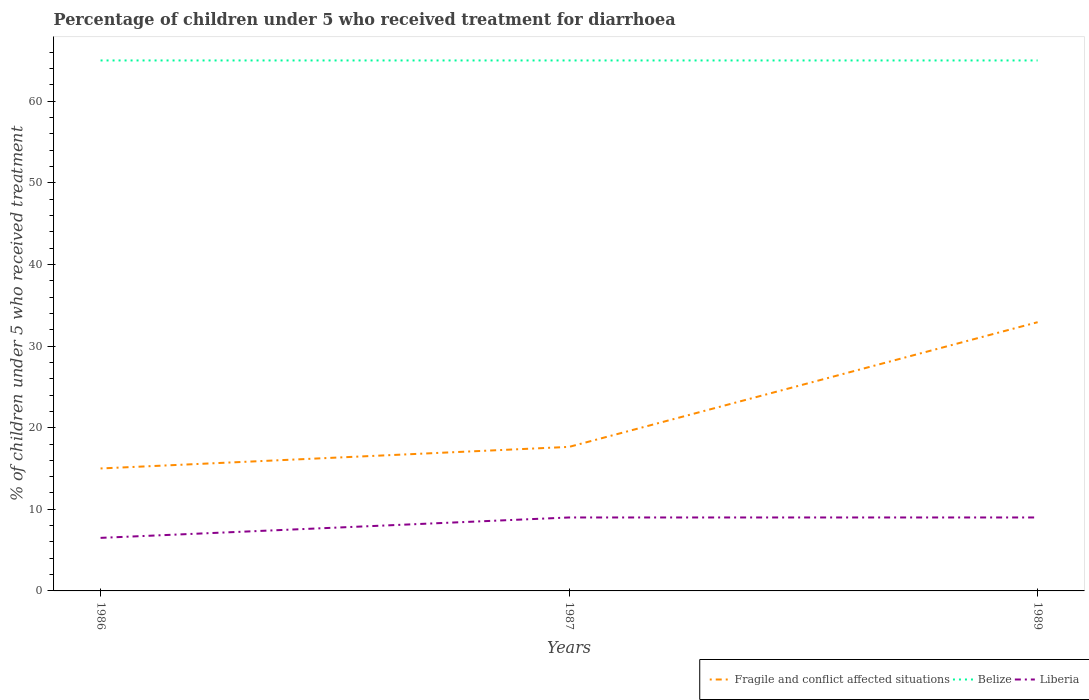How many different coloured lines are there?
Your response must be concise. 3. Across all years, what is the maximum percentage of children who received treatment for diarrhoea  in Fragile and conflict affected situations?
Offer a terse response. 15.01. What is the total percentage of children who received treatment for diarrhoea  in Fragile and conflict affected situations in the graph?
Ensure brevity in your answer.  -2.64. What is the difference between the highest and the second highest percentage of children who received treatment for diarrhoea  in Fragile and conflict affected situations?
Ensure brevity in your answer.  17.92. Is the percentage of children who received treatment for diarrhoea  in Liberia strictly greater than the percentage of children who received treatment for diarrhoea  in Belize over the years?
Your answer should be very brief. Yes. How many years are there in the graph?
Give a very brief answer. 3. What is the difference between two consecutive major ticks on the Y-axis?
Make the answer very short. 10. Are the values on the major ticks of Y-axis written in scientific E-notation?
Offer a very short reply. No. Where does the legend appear in the graph?
Offer a very short reply. Bottom right. What is the title of the graph?
Make the answer very short. Percentage of children under 5 who received treatment for diarrhoea. What is the label or title of the Y-axis?
Give a very brief answer. % of children under 5 who received treatment. What is the % of children under 5 who received treatment of Fragile and conflict affected situations in 1986?
Give a very brief answer. 15.01. What is the % of children under 5 who received treatment of Liberia in 1986?
Provide a short and direct response. 6.5. What is the % of children under 5 who received treatment in Fragile and conflict affected situations in 1987?
Give a very brief answer. 17.65. What is the % of children under 5 who received treatment of Liberia in 1987?
Offer a very short reply. 9. What is the % of children under 5 who received treatment in Fragile and conflict affected situations in 1989?
Offer a terse response. 32.93. What is the % of children under 5 who received treatment in Belize in 1989?
Your answer should be very brief. 65. What is the % of children under 5 who received treatment of Liberia in 1989?
Keep it short and to the point. 9. Across all years, what is the maximum % of children under 5 who received treatment in Fragile and conflict affected situations?
Your answer should be very brief. 32.93. Across all years, what is the maximum % of children under 5 who received treatment in Belize?
Your response must be concise. 65. Across all years, what is the maximum % of children under 5 who received treatment of Liberia?
Give a very brief answer. 9. Across all years, what is the minimum % of children under 5 who received treatment in Fragile and conflict affected situations?
Offer a very short reply. 15.01. Across all years, what is the minimum % of children under 5 who received treatment of Liberia?
Your answer should be very brief. 6.5. What is the total % of children under 5 who received treatment in Fragile and conflict affected situations in the graph?
Your answer should be very brief. 65.58. What is the total % of children under 5 who received treatment of Belize in the graph?
Give a very brief answer. 195. What is the total % of children under 5 who received treatment in Liberia in the graph?
Your response must be concise. 24.5. What is the difference between the % of children under 5 who received treatment of Fragile and conflict affected situations in 1986 and that in 1987?
Give a very brief answer. -2.64. What is the difference between the % of children under 5 who received treatment in Belize in 1986 and that in 1987?
Your answer should be compact. 0. What is the difference between the % of children under 5 who received treatment in Liberia in 1986 and that in 1987?
Offer a very short reply. -2.5. What is the difference between the % of children under 5 who received treatment in Fragile and conflict affected situations in 1986 and that in 1989?
Offer a terse response. -17.92. What is the difference between the % of children under 5 who received treatment in Belize in 1986 and that in 1989?
Your response must be concise. 0. What is the difference between the % of children under 5 who received treatment in Fragile and conflict affected situations in 1987 and that in 1989?
Provide a short and direct response. -15.28. What is the difference between the % of children under 5 who received treatment of Fragile and conflict affected situations in 1986 and the % of children under 5 who received treatment of Belize in 1987?
Make the answer very short. -49.99. What is the difference between the % of children under 5 who received treatment in Fragile and conflict affected situations in 1986 and the % of children under 5 who received treatment in Liberia in 1987?
Offer a very short reply. 6.01. What is the difference between the % of children under 5 who received treatment of Belize in 1986 and the % of children under 5 who received treatment of Liberia in 1987?
Give a very brief answer. 56. What is the difference between the % of children under 5 who received treatment of Fragile and conflict affected situations in 1986 and the % of children under 5 who received treatment of Belize in 1989?
Give a very brief answer. -49.99. What is the difference between the % of children under 5 who received treatment of Fragile and conflict affected situations in 1986 and the % of children under 5 who received treatment of Liberia in 1989?
Your response must be concise. 6.01. What is the difference between the % of children under 5 who received treatment of Fragile and conflict affected situations in 1987 and the % of children under 5 who received treatment of Belize in 1989?
Provide a succinct answer. -47.35. What is the difference between the % of children under 5 who received treatment of Fragile and conflict affected situations in 1987 and the % of children under 5 who received treatment of Liberia in 1989?
Offer a very short reply. 8.65. What is the average % of children under 5 who received treatment in Fragile and conflict affected situations per year?
Your answer should be compact. 21.86. What is the average % of children under 5 who received treatment of Belize per year?
Make the answer very short. 65. What is the average % of children under 5 who received treatment of Liberia per year?
Your answer should be very brief. 8.17. In the year 1986, what is the difference between the % of children under 5 who received treatment in Fragile and conflict affected situations and % of children under 5 who received treatment in Belize?
Provide a succinct answer. -49.99. In the year 1986, what is the difference between the % of children under 5 who received treatment in Fragile and conflict affected situations and % of children under 5 who received treatment in Liberia?
Offer a terse response. 8.51. In the year 1986, what is the difference between the % of children under 5 who received treatment of Belize and % of children under 5 who received treatment of Liberia?
Provide a succinct answer. 58.5. In the year 1987, what is the difference between the % of children under 5 who received treatment of Fragile and conflict affected situations and % of children under 5 who received treatment of Belize?
Ensure brevity in your answer.  -47.35. In the year 1987, what is the difference between the % of children under 5 who received treatment of Fragile and conflict affected situations and % of children under 5 who received treatment of Liberia?
Offer a terse response. 8.65. In the year 1989, what is the difference between the % of children under 5 who received treatment in Fragile and conflict affected situations and % of children under 5 who received treatment in Belize?
Provide a succinct answer. -32.07. In the year 1989, what is the difference between the % of children under 5 who received treatment in Fragile and conflict affected situations and % of children under 5 who received treatment in Liberia?
Offer a terse response. 23.93. What is the ratio of the % of children under 5 who received treatment in Fragile and conflict affected situations in 1986 to that in 1987?
Your response must be concise. 0.85. What is the ratio of the % of children under 5 who received treatment of Belize in 1986 to that in 1987?
Provide a short and direct response. 1. What is the ratio of the % of children under 5 who received treatment of Liberia in 1986 to that in 1987?
Provide a succinct answer. 0.72. What is the ratio of the % of children under 5 who received treatment in Fragile and conflict affected situations in 1986 to that in 1989?
Your response must be concise. 0.46. What is the ratio of the % of children under 5 who received treatment of Liberia in 1986 to that in 1989?
Ensure brevity in your answer.  0.72. What is the ratio of the % of children under 5 who received treatment of Fragile and conflict affected situations in 1987 to that in 1989?
Make the answer very short. 0.54. What is the ratio of the % of children under 5 who received treatment of Liberia in 1987 to that in 1989?
Your answer should be very brief. 1. What is the difference between the highest and the second highest % of children under 5 who received treatment in Fragile and conflict affected situations?
Your answer should be compact. 15.28. What is the difference between the highest and the second highest % of children under 5 who received treatment in Belize?
Ensure brevity in your answer.  0. What is the difference between the highest and the lowest % of children under 5 who received treatment of Fragile and conflict affected situations?
Your answer should be compact. 17.92. What is the difference between the highest and the lowest % of children under 5 who received treatment in Liberia?
Provide a short and direct response. 2.5. 